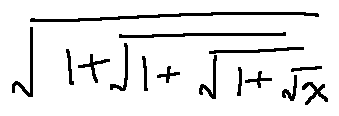<formula> <loc_0><loc_0><loc_500><loc_500>\sqrt { 1 + \sqrt { 1 + \sqrt { 1 + \sqrt { x } } } }</formula> 